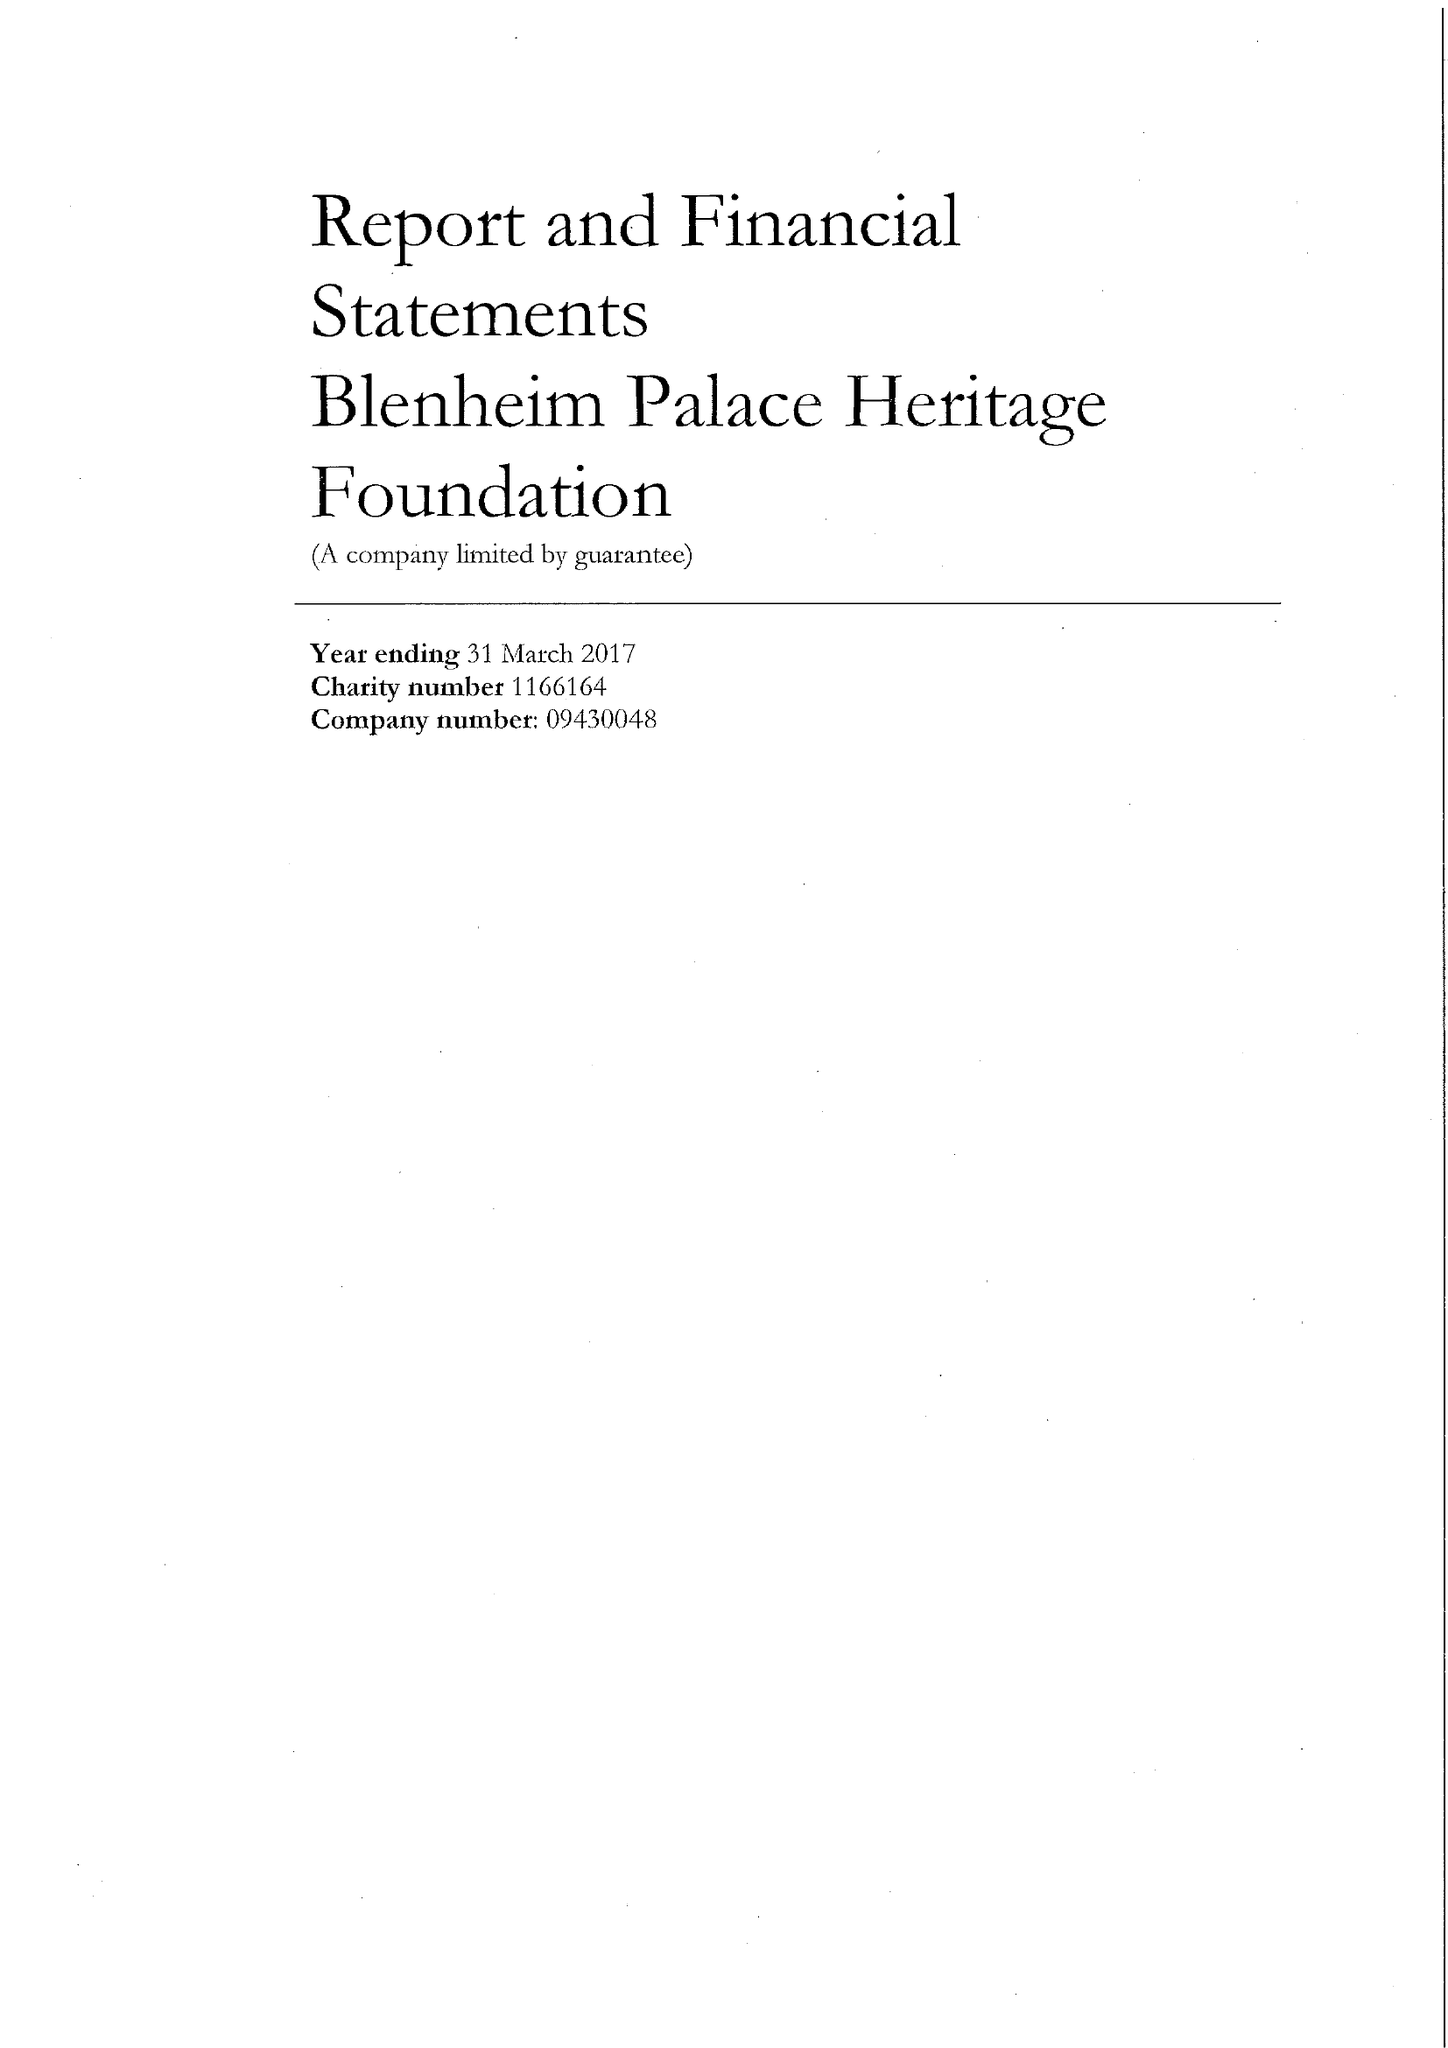What is the value for the address__postcode?
Answer the question using a single word or phrase. OX20 1PS 